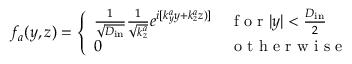<formula> <loc_0><loc_0><loc_500><loc_500>f _ { a } ( y , z ) = \left \{ \begin{array} { l l } { \frac { 1 } { \sqrt { D _ { i n } } } \frac { 1 } { \sqrt { k _ { z } ^ { a } } } e ^ { i [ k _ { y } ^ { a } y + k _ { z } ^ { a } z ) ] } } & { f o r | y | < \frac { D _ { i n } } { 2 } } \\ { 0 } & { o t h e r w i s e } \end{array}</formula> 